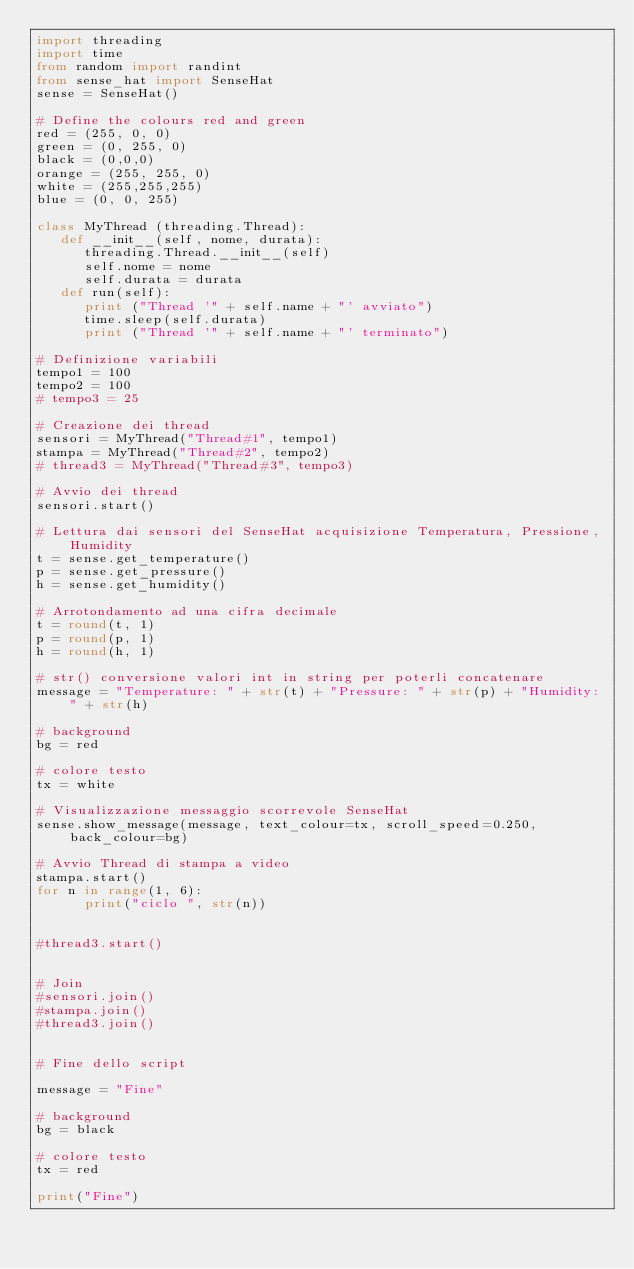<code> <loc_0><loc_0><loc_500><loc_500><_Python_>import threading
import time
from random import randint
from sense_hat import SenseHat
sense = SenseHat()

# Define the colours red and green
red = (255, 0, 0)
green = (0, 255, 0)
black = (0,0,0)
orange = (255, 255, 0)
white = (255,255,255)
blue = (0, 0, 255)

class MyThread (threading.Thread):
   def __init__(self, nome, durata):
      threading.Thread.__init__(self)
      self.nome = nome
      self.durata = durata
   def run(self):
      print ("Thread '" + self.name + "' avviato") 
      time.sleep(self.durata)
      print ("Thread '" + self.name + "' terminato")
     
# Definizione variabili
tempo1 = 100
tempo2 = 100
# tempo3 = 25

# Creazione dei thread
sensori = MyThread("Thread#1", tempo1)
stampa = MyThread("Thread#2", tempo2)
# thread3 = MyThread("Thread#3", tempo3)
 
# Avvio dei thread
sensori.start() 

# Lettura dai sensori del SenseHat acquisizione Temperatura, Pressione, Humidity
t = sense.get_temperature()
p = sense.get_pressure()
h = sense.get_humidity()

# Arrotondamento ad una cifra decimale
t = round(t, 1)
p = round(p, 1)
h = round(h, 1)

# str() conversione valori int in string per poterli concatenare 
message = "Temperature: " + str(t) + "Pressure: " + str(p) + "Humidity: " + str(h)

# background
bg = red
      
# colore testo
tx = white
      
# Visualizzazione messaggio scorrevole SenseHat
sense.show_message(message, text_colour=tx, scroll_speed=0.250, back_colour=bg)

# Avvio Thread di stampa a video
stampa.start()
for n in range(1, 6):
      print("ciclo ", str(n))


#thread3.start()

     
# Join
#sensori.join()
#stampa.join()
#thread3.join()


# Fine dello script 

message = "Fine" 

# background
bg = black
      
# colore testo
tx = red

print("Fine")




</code> 